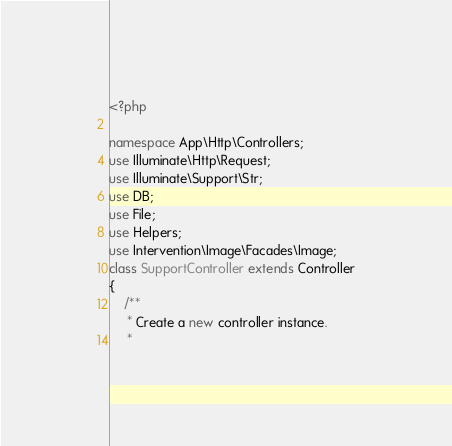<code> <loc_0><loc_0><loc_500><loc_500><_PHP_><?php

namespace App\Http\Controllers;
use Illuminate\Http\Request;
use Illuminate\Support\Str;
use DB;
use File;
use Helpers;
use Intervention\Image\Facades\Image;
class SupportController extends Controller
{
    /**
     * Create a new controller instance.
     *</code> 